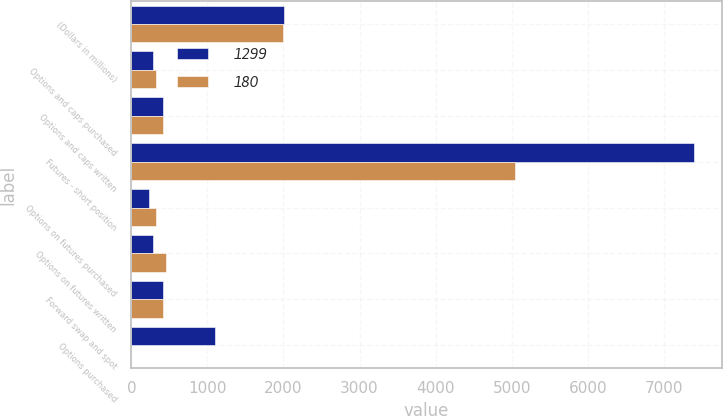Convert chart to OTSL. <chart><loc_0><loc_0><loc_500><loc_500><stacked_bar_chart><ecel><fcel>(Dollars in millions)<fcel>Options and caps purchased<fcel>Options and caps written<fcel>Futures - short position<fcel>Options on futures purchased<fcel>Options on futures written<fcel>Forward swap and spot<fcel>Options purchased<nl><fcel>1299<fcel>2001<fcel>281<fcel>418<fcel>7395<fcel>235<fcel>285<fcel>415.5<fcel>1097<nl><fcel>180<fcel>2000<fcel>323<fcel>413<fcel>5046<fcel>320<fcel>460<fcel>415.5<fcel>2<nl></chart> 